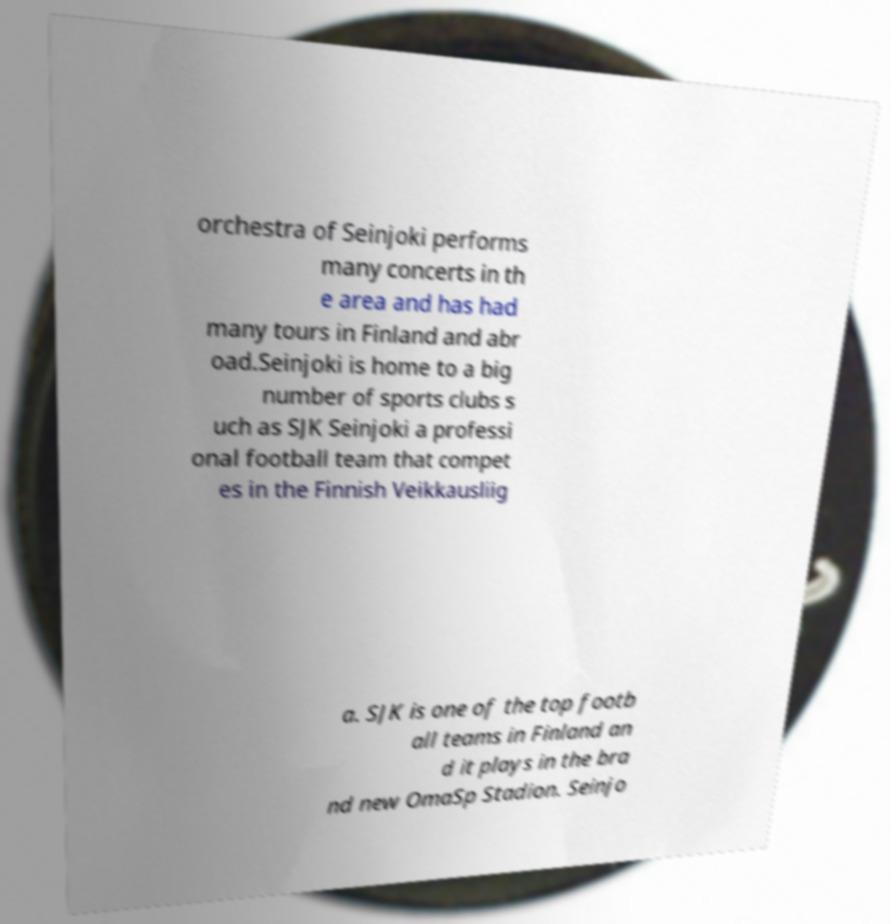Could you extract and type out the text from this image? orchestra of Seinjoki performs many concerts in th e area and has had many tours in Finland and abr oad.Seinjoki is home to a big number of sports clubs s uch as SJK Seinjoki a professi onal football team that compet es in the Finnish Veikkausliig a. SJK is one of the top footb all teams in Finland an d it plays in the bra nd new OmaSp Stadion. Seinjo 